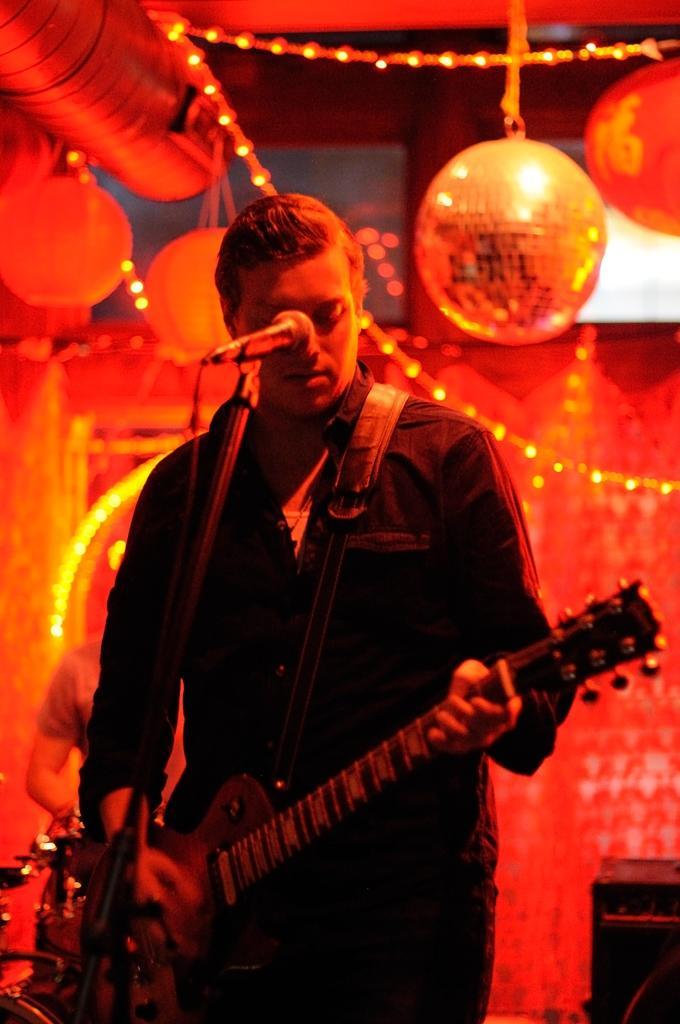Please provide a concise description of this image. I could see a person holding a guitar and a mic is in front of him he is dressed in a black colored shirt. In the left side of the picture i could see a person in the back ground with some musical instruments and in the right corner there is black colored box and in the background there is decorative things hanging over from the ceiling and a serial lights also hanging over. 